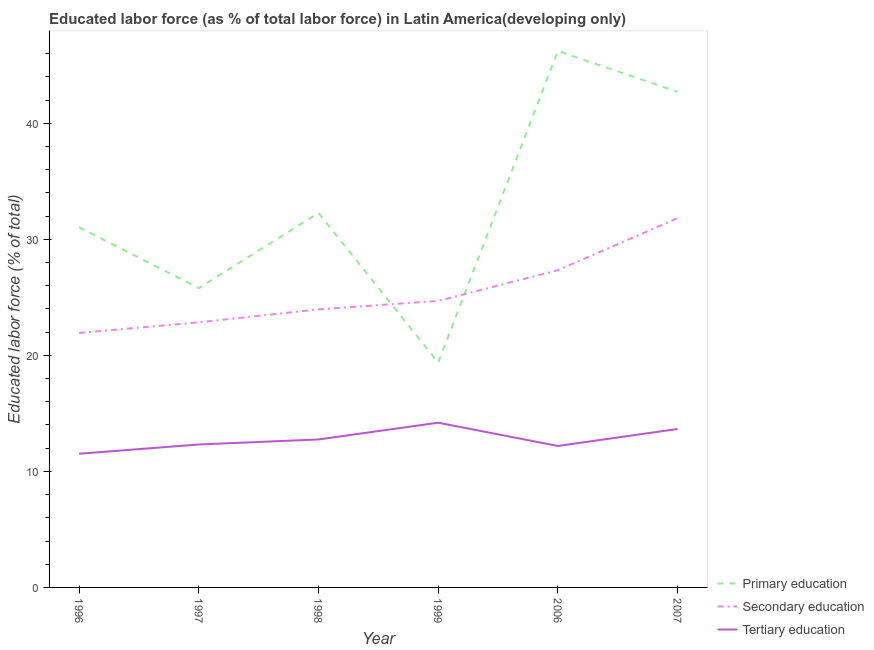How many different coloured lines are there?
Your response must be concise. 3. Is the number of lines equal to the number of legend labels?
Provide a succinct answer. Yes. What is the percentage of labor force who received primary education in 2006?
Give a very brief answer. 46.24. Across all years, what is the maximum percentage of labor force who received primary education?
Give a very brief answer. 46.24. Across all years, what is the minimum percentage of labor force who received primary education?
Provide a succinct answer. 19.38. In which year was the percentage of labor force who received tertiary education minimum?
Keep it short and to the point. 1996. What is the total percentage of labor force who received secondary education in the graph?
Offer a very short reply. 152.61. What is the difference between the percentage of labor force who received tertiary education in 1999 and that in 2006?
Your answer should be very brief. 2.01. What is the difference between the percentage of labor force who received secondary education in 2007 and the percentage of labor force who received primary education in 1996?
Ensure brevity in your answer.  0.78. What is the average percentage of labor force who received primary education per year?
Provide a short and direct response. 32.91. In the year 1998, what is the difference between the percentage of labor force who received tertiary education and percentage of labor force who received primary education?
Offer a very short reply. -19.52. What is the ratio of the percentage of labor force who received tertiary education in 2006 to that in 2007?
Keep it short and to the point. 0.89. Is the percentage of labor force who received secondary education in 1996 less than that in 2006?
Ensure brevity in your answer.  Yes. Is the difference between the percentage of labor force who received tertiary education in 1998 and 2006 greater than the difference between the percentage of labor force who received secondary education in 1998 and 2006?
Keep it short and to the point. Yes. What is the difference between the highest and the second highest percentage of labor force who received tertiary education?
Offer a terse response. 0.54. What is the difference between the highest and the lowest percentage of labor force who received secondary education?
Your response must be concise. 9.89. Is the sum of the percentage of labor force who received primary education in 1998 and 1999 greater than the maximum percentage of labor force who received secondary education across all years?
Make the answer very short. Yes. Is it the case that in every year, the sum of the percentage of labor force who received primary education and percentage of labor force who received secondary education is greater than the percentage of labor force who received tertiary education?
Make the answer very short. Yes. Is the percentage of labor force who received primary education strictly greater than the percentage of labor force who received tertiary education over the years?
Your answer should be compact. Yes. How many lines are there?
Ensure brevity in your answer.  3. What is the difference between two consecutive major ticks on the Y-axis?
Provide a succinct answer. 10. Are the values on the major ticks of Y-axis written in scientific E-notation?
Make the answer very short. No. Does the graph contain grids?
Give a very brief answer. No. How many legend labels are there?
Keep it short and to the point. 3. What is the title of the graph?
Provide a succinct answer. Educated labor force (as % of total labor force) in Latin America(developing only). Does "Domestic" appear as one of the legend labels in the graph?
Keep it short and to the point. No. What is the label or title of the X-axis?
Give a very brief answer. Year. What is the label or title of the Y-axis?
Keep it short and to the point. Educated labor force (% of total). What is the Educated labor force (% of total) of Primary education in 1996?
Your answer should be very brief. 31.05. What is the Educated labor force (% of total) of Secondary education in 1996?
Ensure brevity in your answer.  21.93. What is the Educated labor force (% of total) of Tertiary education in 1996?
Your response must be concise. 11.52. What is the Educated labor force (% of total) of Primary education in 1997?
Provide a succinct answer. 25.79. What is the Educated labor force (% of total) in Secondary education in 1997?
Provide a short and direct response. 22.85. What is the Educated labor force (% of total) of Tertiary education in 1997?
Make the answer very short. 12.32. What is the Educated labor force (% of total) of Primary education in 1998?
Give a very brief answer. 32.28. What is the Educated labor force (% of total) of Secondary education in 1998?
Ensure brevity in your answer.  23.97. What is the Educated labor force (% of total) of Tertiary education in 1998?
Your answer should be compact. 12.75. What is the Educated labor force (% of total) of Primary education in 1999?
Make the answer very short. 19.38. What is the Educated labor force (% of total) of Secondary education in 1999?
Offer a very short reply. 24.69. What is the Educated labor force (% of total) of Tertiary education in 1999?
Ensure brevity in your answer.  14.2. What is the Educated labor force (% of total) of Primary education in 2006?
Offer a very short reply. 46.24. What is the Educated labor force (% of total) in Secondary education in 2006?
Provide a succinct answer. 27.34. What is the Educated labor force (% of total) in Tertiary education in 2006?
Your response must be concise. 12.19. What is the Educated labor force (% of total) of Primary education in 2007?
Ensure brevity in your answer.  42.71. What is the Educated labor force (% of total) in Secondary education in 2007?
Keep it short and to the point. 31.83. What is the Educated labor force (% of total) of Tertiary education in 2007?
Ensure brevity in your answer.  13.66. Across all years, what is the maximum Educated labor force (% of total) in Primary education?
Your response must be concise. 46.24. Across all years, what is the maximum Educated labor force (% of total) of Secondary education?
Keep it short and to the point. 31.83. Across all years, what is the maximum Educated labor force (% of total) in Tertiary education?
Provide a succinct answer. 14.2. Across all years, what is the minimum Educated labor force (% of total) in Primary education?
Provide a succinct answer. 19.38. Across all years, what is the minimum Educated labor force (% of total) of Secondary education?
Offer a very short reply. 21.93. Across all years, what is the minimum Educated labor force (% of total) of Tertiary education?
Provide a succinct answer. 11.52. What is the total Educated labor force (% of total) in Primary education in the graph?
Make the answer very short. 197.45. What is the total Educated labor force (% of total) of Secondary education in the graph?
Offer a terse response. 152.61. What is the total Educated labor force (% of total) in Tertiary education in the graph?
Your answer should be very brief. 76.64. What is the difference between the Educated labor force (% of total) of Primary education in 1996 and that in 1997?
Ensure brevity in your answer.  5.25. What is the difference between the Educated labor force (% of total) of Secondary education in 1996 and that in 1997?
Make the answer very short. -0.91. What is the difference between the Educated labor force (% of total) of Tertiary education in 1996 and that in 1997?
Your response must be concise. -0.8. What is the difference between the Educated labor force (% of total) of Primary education in 1996 and that in 1998?
Make the answer very short. -1.23. What is the difference between the Educated labor force (% of total) in Secondary education in 1996 and that in 1998?
Make the answer very short. -2.03. What is the difference between the Educated labor force (% of total) in Tertiary education in 1996 and that in 1998?
Offer a terse response. -1.23. What is the difference between the Educated labor force (% of total) in Primary education in 1996 and that in 1999?
Ensure brevity in your answer.  11.67. What is the difference between the Educated labor force (% of total) of Secondary education in 1996 and that in 1999?
Your answer should be compact. -2.76. What is the difference between the Educated labor force (% of total) of Tertiary education in 1996 and that in 1999?
Keep it short and to the point. -2.68. What is the difference between the Educated labor force (% of total) in Primary education in 1996 and that in 2006?
Your answer should be very brief. -15.19. What is the difference between the Educated labor force (% of total) of Secondary education in 1996 and that in 2006?
Offer a terse response. -5.41. What is the difference between the Educated labor force (% of total) in Tertiary education in 1996 and that in 2006?
Provide a short and direct response. -0.67. What is the difference between the Educated labor force (% of total) of Primary education in 1996 and that in 2007?
Make the answer very short. -11.66. What is the difference between the Educated labor force (% of total) in Secondary education in 1996 and that in 2007?
Keep it short and to the point. -9.89. What is the difference between the Educated labor force (% of total) of Tertiary education in 1996 and that in 2007?
Offer a very short reply. -2.13. What is the difference between the Educated labor force (% of total) in Primary education in 1997 and that in 1998?
Offer a very short reply. -6.48. What is the difference between the Educated labor force (% of total) of Secondary education in 1997 and that in 1998?
Offer a very short reply. -1.12. What is the difference between the Educated labor force (% of total) in Tertiary education in 1997 and that in 1998?
Offer a terse response. -0.43. What is the difference between the Educated labor force (% of total) of Primary education in 1997 and that in 1999?
Provide a succinct answer. 6.41. What is the difference between the Educated labor force (% of total) of Secondary education in 1997 and that in 1999?
Your response must be concise. -1.85. What is the difference between the Educated labor force (% of total) in Tertiary education in 1997 and that in 1999?
Your answer should be compact. -1.88. What is the difference between the Educated labor force (% of total) of Primary education in 1997 and that in 2006?
Make the answer very short. -20.44. What is the difference between the Educated labor force (% of total) of Secondary education in 1997 and that in 2006?
Make the answer very short. -4.5. What is the difference between the Educated labor force (% of total) of Tertiary education in 1997 and that in 2006?
Your answer should be compact. 0.13. What is the difference between the Educated labor force (% of total) in Primary education in 1997 and that in 2007?
Give a very brief answer. -16.92. What is the difference between the Educated labor force (% of total) of Secondary education in 1997 and that in 2007?
Your answer should be compact. -8.98. What is the difference between the Educated labor force (% of total) of Tertiary education in 1997 and that in 2007?
Provide a short and direct response. -1.34. What is the difference between the Educated labor force (% of total) in Primary education in 1998 and that in 1999?
Ensure brevity in your answer.  12.89. What is the difference between the Educated labor force (% of total) of Secondary education in 1998 and that in 1999?
Provide a succinct answer. -0.73. What is the difference between the Educated labor force (% of total) of Tertiary education in 1998 and that in 1999?
Your response must be concise. -1.45. What is the difference between the Educated labor force (% of total) in Primary education in 1998 and that in 2006?
Provide a short and direct response. -13.96. What is the difference between the Educated labor force (% of total) in Secondary education in 1998 and that in 2006?
Offer a very short reply. -3.38. What is the difference between the Educated labor force (% of total) of Tertiary education in 1998 and that in 2006?
Ensure brevity in your answer.  0.56. What is the difference between the Educated labor force (% of total) in Primary education in 1998 and that in 2007?
Your answer should be compact. -10.44. What is the difference between the Educated labor force (% of total) in Secondary education in 1998 and that in 2007?
Keep it short and to the point. -7.86. What is the difference between the Educated labor force (% of total) in Tertiary education in 1998 and that in 2007?
Your response must be concise. -0.9. What is the difference between the Educated labor force (% of total) of Primary education in 1999 and that in 2006?
Offer a terse response. -26.85. What is the difference between the Educated labor force (% of total) in Secondary education in 1999 and that in 2006?
Provide a short and direct response. -2.65. What is the difference between the Educated labor force (% of total) in Tertiary education in 1999 and that in 2006?
Keep it short and to the point. 2.01. What is the difference between the Educated labor force (% of total) in Primary education in 1999 and that in 2007?
Your response must be concise. -23.33. What is the difference between the Educated labor force (% of total) of Secondary education in 1999 and that in 2007?
Provide a short and direct response. -7.13. What is the difference between the Educated labor force (% of total) in Tertiary education in 1999 and that in 2007?
Offer a very short reply. 0.54. What is the difference between the Educated labor force (% of total) of Primary education in 2006 and that in 2007?
Your answer should be compact. 3.52. What is the difference between the Educated labor force (% of total) of Secondary education in 2006 and that in 2007?
Keep it short and to the point. -4.48. What is the difference between the Educated labor force (% of total) of Tertiary education in 2006 and that in 2007?
Offer a very short reply. -1.46. What is the difference between the Educated labor force (% of total) of Primary education in 1996 and the Educated labor force (% of total) of Secondary education in 1997?
Provide a short and direct response. 8.2. What is the difference between the Educated labor force (% of total) of Primary education in 1996 and the Educated labor force (% of total) of Tertiary education in 1997?
Keep it short and to the point. 18.73. What is the difference between the Educated labor force (% of total) in Secondary education in 1996 and the Educated labor force (% of total) in Tertiary education in 1997?
Give a very brief answer. 9.61. What is the difference between the Educated labor force (% of total) in Primary education in 1996 and the Educated labor force (% of total) in Secondary education in 1998?
Offer a very short reply. 7.08. What is the difference between the Educated labor force (% of total) of Primary education in 1996 and the Educated labor force (% of total) of Tertiary education in 1998?
Keep it short and to the point. 18.3. What is the difference between the Educated labor force (% of total) in Secondary education in 1996 and the Educated labor force (% of total) in Tertiary education in 1998?
Offer a very short reply. 9.18. What is the difference between the Educated labor force (% of total) in Primary education in 1996 and the Educated labor force (% of total) in Secondary education in 1999?
Offer a very short reply. 6.35. What is the difference between the Educated labor force (% of total) of Primary education in 1996 and the Educated labor force (% of total) of Tertiary education in 1999?
Offer a terse response. 16.85. What is the difference between the Educated labor force (% of total) in Secondary education in 1996 and the Educated labor force (% of total) in Tertiary education in 1999?
Provide a short and direct response. 7.73. What is the difference between the Educated labor force (% of total) of Primary education in 1996 and the Educated labor force (% of total) of Secondary education in 2006?
Your answer should be very brief. 3.7. What is the difference between the Educated labor force (% of total) of Primary education in 1996 and the Educated labor force (% of total) of Tertiary education in 2006?
Your answer should be compact. 18.86. What is the difference between the Educated labor force (% of total) of Secondary education in 1996 and the Educated labor force (% of total) of Tertiary education in 2006?
Keep it short and to the point. 9.74. What is the difference between the Educated labor force (% of total) of Primary education in 1996 and the Educated labor force (% of total) of Secondary education in 2007?
Keep it short and to the point. -0.78. What is the difference between the Educated labor force (% of total) of Primary education in 1996 and the Educated labor force (% of total) of Tertiary education in 2007?
Your answer should be compact. 17.39. What is the difference between the Educated labor force (% of total) in Secondary education in 1996 and the Educated labor force (% of total) in Tertiary education in 2007?
Keep it short and to the point. 8.28. What is the difference between the Educated labor force (% of total) of Primary education in 1997 and the Educated labor force (% of total) of Secondary education in 1998?
Offer a terse response. 1.83. What is the difference between the Educated labor force (% of total) of Primary education in 1997 and the Educated labor force (% of total) of Tertiary education in 1998?
Offer a very short reply. 13.04. What is the difference between the Educated labor force (% of total) in Secondary education in 1997 and the Educated labor force (% of total) in Tertiary education in 1998?
Ensure brevity in your answer.  10.09. What is the difference between the Educated labor force (% of total) of Primary education in 1997 and the Educated labor force (% of total) of Secondary education in 1999?
Keep it short and to the point. 1.1. What is the difference between the Educated labor force (% of total) in Primary education in 1997 and the Educated labor force (% of total) in Tertiary education in 1999?
Your response must be concise. 11.6. What is the difference between the Educated labor force (% of total) in Secondary education in 1997 and the Educated labor force (% of total) in Tertiary education in 1999?
Provide a succinct answer. 8.65. What is the difference between the Educated labor force (% of total) of Primary education in 1997 and the Educated labor force (% of total) of Secondary education in 2006?
Offer a very short reply. -1.55. What is the difference between the Educated labor force (% of total) of Primary education in 1997 and the Educated labor force (% of total) of Tertiary education in 2006?
Keep it short and to the point. 13.6. What is the difference between the Educated labor force (% of total) in Secondary education in 1997 and the Educated labor force (% of total) in Tertiary education in 2006?
Your answer should be compact. 10.66. What is the difference between the Educated labor force (% of total) in Primary education in 1997 and the Educated labor force (% of total) in Secondary education in 2007?
Offer a terse response. -6.03. What is the difference between the Educated labor force (% of total) of Primary education in 1997 and the Educated labor force (% of total) of Tertiary education in 2007?
Give a very brief answer. 12.14. What is the difference between the Educated labor force (% of total) in Secondary education in 1997 and the Educated labor force (% of total) in Tertiary education in 2007?
Ensure brevity in your answer.  9.19. What is the difference between the Educated labor force (% of total) of Primary education in 1998 and the Educated labor force (% of total) of Secondary education in 1999?
Ensure brevity in your answer.  7.58. What is the difference between the Educated labor force (% of total) in Primary education in 1998 and the Educated labor force (% of total) in Tertiary education in 1999?
Your answer should be very brief. 18.08. What is the difference between the Educated labor force (% of total) of Secondary education in 1998 and the Educated labor force (% of total) of Tertiary education in 1999?
Ensure brevity in your answer.  9.77. What is the difference between the Educated labor force (% of total) of Primary education in 1998 and the Educated labor force (% of total) of Secondary education in 2006?
Your answer should be compact. 4.93. What is the difference between the Educated labor force (% of total) of Primary education in 1998 and the Educated labor force (% of total) of Tertiary education in 2006?
Ensure brevity in your answer.  20.08. What is the difference between the Educated labor force (% of total) in Secondary education in 1998 and the Educated labor force (% of total) in Tertiary education in 2006?
Offer a very short reply. 11.77. What is the difference between the Educated labor force (% of total) in Primary education in 1998 and the Educated labor force (% of total) in Secondary education in 2007?
Provide a short and direct response. 0.45. What is the difference between the Educated labor force (% of total) in Primary education in 1998 and the Educated labor force (% of total) in Tertiary education in 2007?
Your answer should be very brief. 18.62. What is the difference between the Educated labor force (% of total) in Secondary education in 1998 and the Educated labor force (% of total) in Tertiary education in 2007?
Ensure brevity in your answer.  10.31. What is the difference between the Educated labor force (% of total) of Primary education in 1999 and the Educated labor force (% of total) of Secondary education in 2006?
Ensure brevity in your answer.  -7.96. What is the difference between the Educated labor force (% of total) of Primary education in 1999 and the Educated labor force (% of total) of Tertiary education in 2006?
Provide a short and direct response. 7.19. What is the difference between the Educated labor force (% of total) in Secondary education in 1999 and the Educated labor force (% of total) in Tertiary education in 2006?
Give a very brief answer. 12.5. What is the difference between the Educated labor force (% of total) in Primary education in 1999 and the Educated labor force (% of total) in Secondary education in 2007?
Provide a succinct answer. -12.45. What is the difference between the Educated labor force (% of total) of Primary education in 1999 and the Educated labor force (% of total) of Tertiary education in 2007?
Provide a short and direct response. 5.72. What is the difference between the Educated labor force (% of total) in Secondary education in 1999 and the Educated labor force (% of total) in Tertiary education in 2007?
Provide a short and direct response. 11.04. What is the difference between the Educated labor force (% of total) in Primary education in 2006 and the Educated labor force (% of total) in Secondary education in 2007?
Offer a terse response. 14.41. What is the difference between the Educated labor force (% of total) in Primary education in 2006 and the Educated labor force (% of total) in Tertiary education in 2007?
Provide a succinct answer. 32.58. What is the difference between the Educated labor force (% of total) of Secondary education in 2006 and the Educated labor force (% of total) of Tertiary education in 2007?
Offer a very short reply. 13.69. What is the average Educated labor force (% of total) in Primary education per year?
Provide a succinct answer. 32.91. What is the average Educated labor force (% of total) of Secondary education per year?
Ensure brevity in your answer.  25.44. What is the average Educated labor force (% of total) in Tertiary education per year?
Provide a short and direct response. 12.77. In the year 1996, what is the difference between the Educated labor force (% of total) in Primary education and Educated labor force (% of total) in Secondary education?
Make the answer very short. 9.12. In the year 1996, what is the difference between the Educated labor force (% of total) of Primary education and Educated labor force (% of total) of Tertiary education?
Make the answer very short. 19.53. In the year 1996, what is the difference between the Educated labor force (% of total) of Secondary education and Educated labor force (% of total) of Tertiary education?
Offer a terse response. 10.41. In the year 1997, what is the difference between the Educated labor force (% of total) of Primary education and Educated labor force (% of total) of Secondary education?
Your answer should be compact. 2.95. In the year 1997, what is the difference between the Educated labor force (% of total) in Primary education and Educated labor force (% of total) in Tertiary education?
Provide a succinct answer. 13.47. In the year 1997, what is the difference between the Educated labor force (% of total) of Secondary education and Educated labor force (% of total) of Tertiary education?
Keep it short and to the point. 10.53. In the year 1998, what is the difference between the Educated labor force (% of total) of Primary education and Educated labor force (% of total) of Secondary education?
Ensure brevity in your answer.  8.31. In the year 1998, what is the difference between the Educated labor force (% of total) in Primary education and Educated labor force (% of total) in Tertiary education?
Provide a short and direct response. 19.52. In the year 1998, what is the difference between the Educated labor force (% of total) in Secondary education and Educated labor force (% of total) in Tertiary education?
Your response must be concise. 11.21. In the year 1999, what is the difference between the Educated labor force (% of total) in Primary education and Educated labor force (% of total) in Secondary education?
Make the answer very short. -5.31. In the year 1999, what is the difference between the Educated labor force (% of total) in Primary education and Educated labor force (% of total) in Tertiary education?
Make the answer very short. 5.18. In the year 1999, what is the difference between the Educated labor force (% of total) of Secondary education and Educated labor force (% of total) of Tertiary education?
Your answer should be compact. 10.5. In the year 2006, what is the difference between the Educated labor force (% of total) of Primary education and Educated labor force (% of total) of Secondary education?
Offer a terse response. 18.89. In the year 2006, what is the difference between the Educated labor force (% of total) of Primary education and Educated labor force (% of total) of Tertiary education?
Your answer should be very brief. 34.04. In the year 2006, what is the difference between the Educated labor force (% of total) in Secondary education and Educated labor force (% of total) in Tertiary education?
Your answer should be very brief. 15.15. In the year 2007, what is the difference between the Educated labor force (% of total) of Primary education and Educated labor force (% of total) of Secondary education?
Provide a succinct answer. 10.89. In the year 2007, what is the difference between the Educated labor force (% of total) of Primary education and Educated labor force (% of total) of Tertiary education?
Provide a short and direct response. 29.06. In the year 2007, what is the difference between the Educated labor force (% of total) of Secondary education and Educated labor force (% of total) of Tertiary education?
Provide a succinct answer. 18.17. What is the ratio of the Educated labor force (% of total) of Primary education in 1996 to that in 1997?
Provide a succinct answer. 1.2. What is the ratio of the Educated labor force (% of total) in Secondary education in 1996 to that in 1997?
Your answer should be compact. 0.96. What is the ratio of the Educated labor force (% of total) in Tertiary education in 1996 to that in 1997?
Make the answer very short. 0.94. What is the ratio of the Educated labor force (% of total) of Secondary education in 1996 to that in 1998?
Provide a short and direct response. 0.92. What is the ratio of the Educated labor force (% of total) in Tertiary education in 1996 to that in 1998?
Keep it short and to the point. 0.9. What is the ratio of the Educated labor force (% of total) in Primary education in 1996 to that in 1999?
Provide a short and direct response. 1.6. What is the ratio of the Educated labor force (% of total) in Secondary education in 1996 to that in 1999?
Provide a short and direct response. 0.89. What is the ratio of the Educated labor force (% of total) of Tertiary education in 1996 to that in 1999?
Keep it short and to the point. 0.81. What is the ratio of the Educated labor force (% of total) of Primary education in 1996 to that in 2006?
Offer a very short reply. 0.67. What is the ratio of the Educated labor force (% of total) in Secondary education in 1996 to that in 2006?
Provide a succinct answer. 0.8. What is the ratio of the Educated labor force (% of total) of Tertiary education in 1996 to that in 2006?
Provide a succinct answer. 0.95. What is the ratio of the Educated labor force (% of total) in Primary education in 1996 to that in 2007?
Offer a terse response. 0.73. What is the ratio of the Educated labor force (% of total) in Secondary education in 1996 to that in 2007?
Make the answer very short. 0.69. What is the ratio of the Educated labor force (% of total) of Tertiary education in 1996 to that in 2007?
Provide a short and direct response. 0.84. What is the ratio of the Educated labor force (% of total) in Primary education in 1997 to that in 1998?
Provide a succinct answer. 0.8. What is the ratio of the Educated labor force (% of total) of Secondary education in 1997 to that in 1998?
Offer a terse response. 0.95. What is the ratio of the Educated labor force (% of total) of Tertiary education in 1997 to that in 1998?
Your answer should be compact. 0.97. What is the ratio of the Educated labor force (% of total) of Primary education in 1997 to that in 1999?
Your response must be concise. 1.33. What is the ratio of the Educated labor force (% of total) of Secondary education in 1997 to that in 1999?
Keep it short and to the point. 0.93. What is the ratio of the Educated labor force (% of total) of Tertiary education in 1997 to that in 1999?
Your response must be concise. 0.87. What is the ratio of the Educated labor force (% of total) of Primary education in 1997 to that in 2006?
Your response must be concise. 0.56. What is the ratio of the Educated labor force (% of total) in Secondary education in 1997 to that in 2006?
Ensure brevity in your answer.  0.84. What is the ratio of the Educated labor force (% of total) of Tertiary education in 1997 to that in 2006?
Your response must be concise. 1.01. What is the ratio of the Educated labor force (% of total) in Primary education in 1997 to that in 2007?
Make the answer very short. 0.6. What is the ratio of the Educated labor force (% of total) of Secondary education in 1997 to that in 2007?
Provide a succinct answer. 0.72. What is the ratio of the Educated labor force (% of total) of Tertiary education in 1997 to that in 2007?
Make the answer very short. 0.9. What is the ratio of the Educated labor force (% of total) in Primary education in 1998 to that in 1999?
Your response must be concise. 1.67. What is the ratio of the Educated labor force (% of total) in Secondary education in 1998 to that in 1999?
Ensure brevity in your answer.  0.97. What is the ratio of the Educated labor force (% of total) in Tertiary education in 1998 to that in 1999?
Provide a short and direct response. 0.9. What is the ratio of the Educated labor force (% of total) of Primary education in 1998 to that in 2006?
Ensure brevity in your answer.  0.7. What is the ratio of the Educated labor force (% of total) of Secondary education in 1998 to that in 2006?
Ensure brevity in your answer.  0.88. What is the ratio of the Educated labor force (% of total) of Tertiary education in 1998 to that in 2006?
Offer a terse response. 1.05. What is the ratio of the Educated labor force (% of total) of Primary education in 1998 to that in 2007?
Offer a very short reply. 0.76. What is the ratio of the Educated labor force (% of total) of Secondary education in 1998 to that in 2007?
Your answer should be very brief. 0.75. What is the ratio of the Educated labor force (% of total) of Tertiary education in 1998 to that in 2007?
Offer a terse response. 0.93. What is the ratio of the Educated labor force (% of total) of Primary education in 1999 to that in 2006?
Your answer should be very brief. 0.42. What is the ratio of the Educated labor force (% of total) of Secondary education in 1999 to that in 2006?
Make the answer very short. 0.9. What is the ratio of the Educated labor force (% of total) of Tertiary education in 1999 to that in 2006?
Provide a short and direct response. 1.16. What is the ratio of the Educated labor force (% of total) in Primary education in 1999 to that in 2007?
Your answer should be very brief. 0.45. What is the ratio of the Educated labor force (% of total) in Secondary education in 1999 to that in 2007?
Keep it short and to the point. 0.78. What is the ratio of the Educated labor force (% of total) of Tertiary education in 1999 to that in 2007?
Your response must be concise. 1.04. What is the ratio of the Educated labor force (% of total) of Primary education in 2006 to that in 2007?
Offer a very short reply. 1.08. What is the ratio of the Educated labor force (% of total) in Secondary education in 2006 to that in 2007?
Ensure brevity in your answer.  0.86. What is the ratio of the Educated labor force (% of total) in Tertiary education in 2006 to that in 2007?
Keep it short and to the point. 0.89. What is the difference between the highest and the second highest Educated labor force (% of total) of Primary education?
Ensure brevity in your answer.  3.52. What is the difference between the highest and the second highest Educated labor force (% of total) of Secondary education?
Make the answer very short. 4.48. What is the difference between the highest and the second highest Educated labor force (% of total) in Tertiary education?
Your answer should be compact. 0.54. What is the difference between the highest and the lowest Educated labor force (% of total) of Primary education?
Make the answer very short. 26.85. What is the difference between the highest and the lowest Educated labor force (% of total) of Secondary education?
Offer a very short reply. 9.89. What is the difference between the highest and the lowest Educated labor force (% of total) in Tertiary education?
Provide a succinct answer. 2.68. 